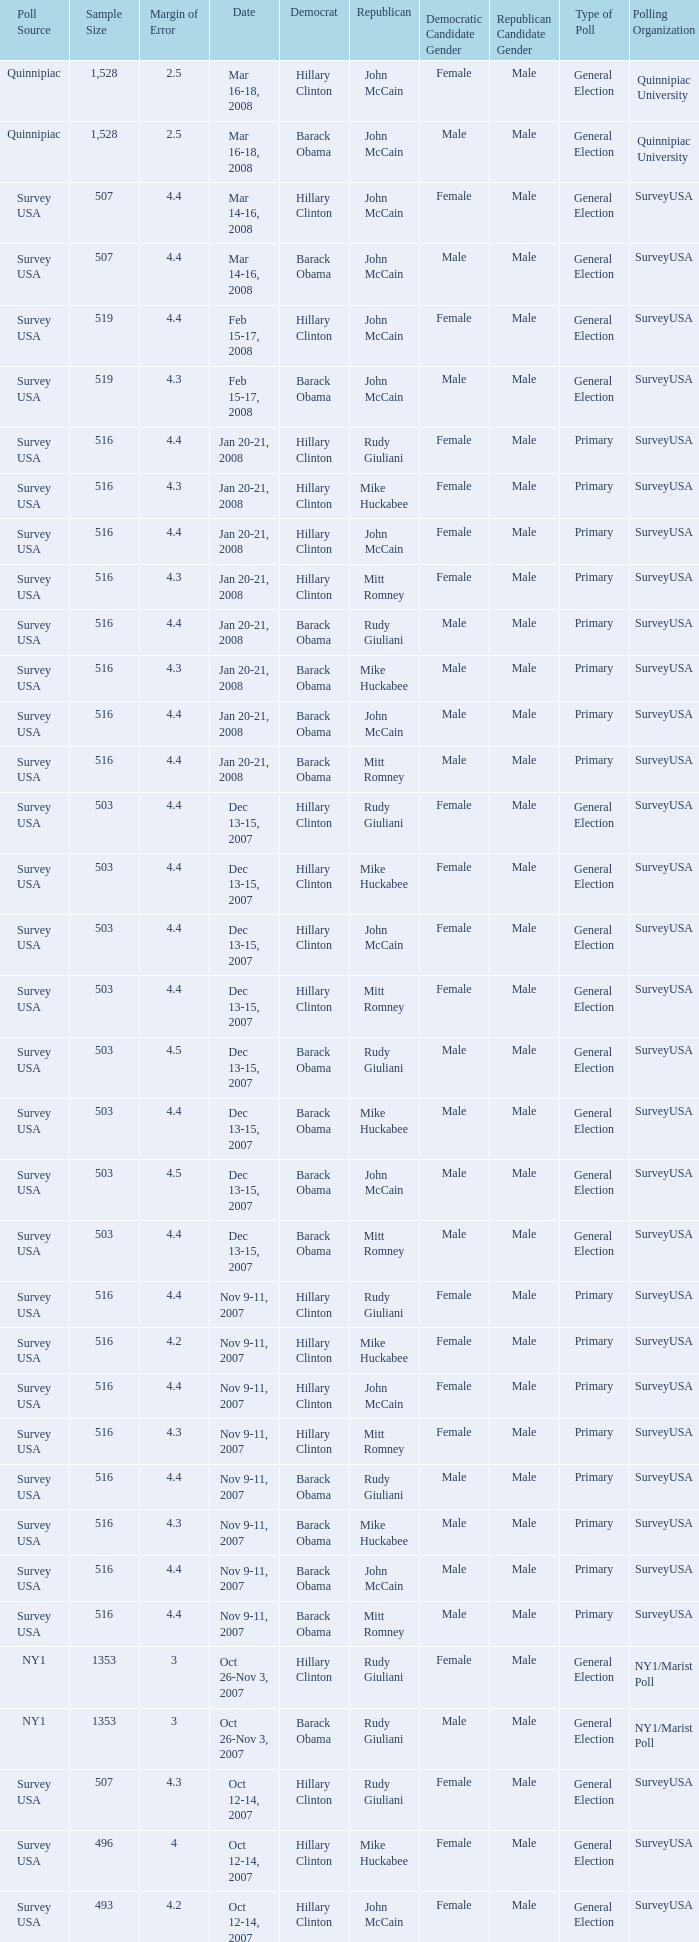What is the sample size of the poll taken on Dec 13-15, 2007 that had a margin of error of more than 4 and resulted with Republican Mike Huckabee? 503.0. 